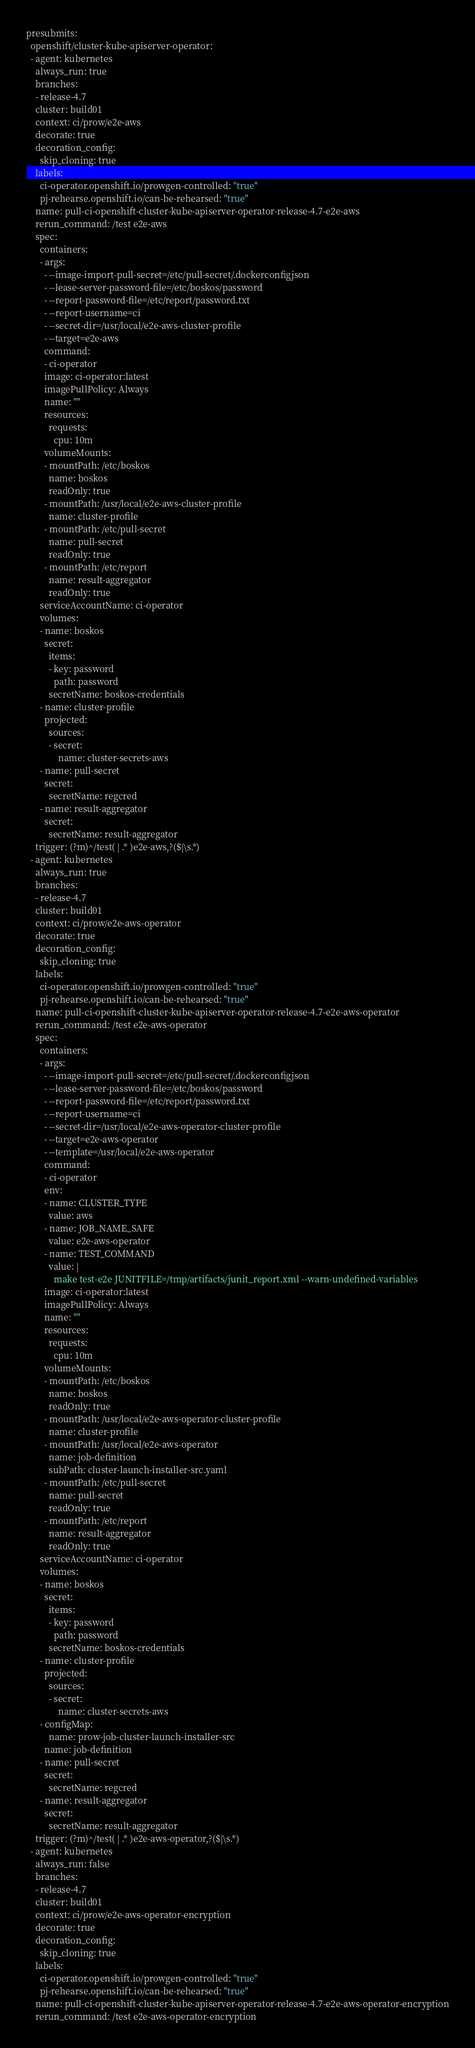<code> <loc_0><loc_0><loc_500><loc_500><_YAML_>presubmits:
  openshift/cluster-kube-apiserver-operator:
  - agent: kubernetes
    always_run: true
    branches:
    - release-4.7
    cluster: build01
    context: ci/prow/e2e-aws
    decorate: true
    decoration_config:
      skip_cloning: true
    labels:
      ci-operator.openshift.io/prowgen-controlled: "true"
      pj-rehearse.openshift.io/can-be-rehearsed: "true"
    name: pull-ci-openshift-cluster-kube-apiserver-operator-release-4.7-e2e-aws
    rerun_command: /test e2e-aws
    spec:
      containers:
      - args:
        - --image-import-pull-secret=/etc/pull-secret/.dockerconfigjson
        - --lease-server-password-file=/etc/boskos/password
        - --report-password-file=/etc/report/password.txt
        - --report-username=ci
        - --secret-dir=/usr/local/e2e-aws-cluster-profile
        - --target=e2e-aws
        command:
        - ci-operator
        image: ci-operator:latest
        imagePullPolicy: Always
        name: ""
        resources:
          requests:
            cpu: 10m
        volumeMounts:
        - mountPath: /etc/boskos
          name: boskos
          readOnly: true
        - mountPath: /usr/local/e2e-aws-cluster-profile
          name: cluster-profile
        - mountPath: /etc/pull-secret
          name: pull-secret
          readOnly: true
        - mountPath: /etc/report
          name: result-aggregator
          readOnly: true
      serviceAccountName: ci-operator
      volumes:
      - name: boskos
        secret:
          items:
          - key: password
            path: password
          secretName: boskos-credentials
      - name: cluster-profile
        projected:
          sources:
          - secret:
              name: cluster-secrets-aws
      - name: pull-secret
        secret:
          secretName: regcred
      - name: result-aggregator
        secret:
          secretName: result-aggregator
    trigger: (?m)^/test( | .* )e2e-aws,?($|\s.*)
  - agent: kubernetes
    always_run: true
    branches:
    - release-4.7
    cluster: build01
    context: ci/prow/e2e-aws-operator
    decorate: true
    decoration_config:
      skip_cloning: true
    labels:
      ci-operator.openshift.io/prowgen-controlled: "true"
      pj-rehearse.openshift.io/can-be-rehearsed: "true"
    name: pull-ci-openshift-cluster-kube-apiserver-operator-release-4.7-e2e-aws-operator
    rerun_command: /test e2e-aws-operator
    spec:
      containers:
      - args:
        - --image-import-pull-secret=/etc/pull-secret/.dockerconfigjson
        - --lease-server-password-file=/etc/boskos/password
        - --report-password-file=/etc/report/password.txt
        - --report-username=ci
        - --secret-dir=/usr/local/e2e-aws-operator-cluster-profile
        - --target=e2e-aws-operator
        - --template=/usr/local/e2e-aws-operator
        command:
        - ci-operator
        env:
        - name: CLUSTER_TYPE
          value: aws
        - name: JOB_NAME_SAFE
          value: e2e-aws-operator
        - name: TEST_COMMAND
          value: |
            make test-e2e JUNITFILE=/tmp/artifacts/junit_report.xml --warn-undefined-variables
        image: ci-operator:latest
        imagePullPolicy: Always
        name: ""
        resources:
          requests:
            cpu: 10m
        volumeMounts:
        - mountPath: /etc/boskos
          name: boskos
          readOnly: true
        - mountPath: /usr/local/e2e-aws-operator-cluster-profile
          name: cluster-profile
        - mountPath: /usr/local/e2e-aws-operator
          name: job-definition
          subPath: cluster-launch-installer-src.yaml
        - mountPath: /etc/pull-secret
          name: pull-secret
          readOnly: true
        - mountPath: /etc/report
          name: result-aggregator
          readOnly: true
      serviceAccountName: ci-operator
      volumes:
      - name: boskos
        secret:
          items:
          - key: password
            path: password
          secretName: boskos-credentials
      - name: cluster-profile
        projected:
          sources:
          - secret:
              name: cluster-secrets-aws
      - configMap:
          name: prow-job-cluster-launch-installer-src
        name: job-definition
      - name: pull-secret
        secret:
          secretName: regcred
      - name: result-aggregator
        secret:
          secretName: result-aggregator
    trigger: (?m)^/test( | .* )e2e-aws-operator,?($|\s.*)
  - agent: kubernetes
    always_run: false
    branches:
    - release-4.7
    cluster: build01
    context: ci/prow/e2e-aws-operator-encryption
    decorate: true
    decoration_config:
      skip_cloning: true
    labels:
      ci-operator.openshift.io/prowgen-controlled: "true"
      pj-rehearse.openshift.io/can-be-rehearsed: "true"
    name: pull-ci-openshift-cluster-kube-apiserver-operator-release-4.7-e2e-aws-operator-encryption
    rerun_command: /test e2e-aws-operator-encryption</code> 